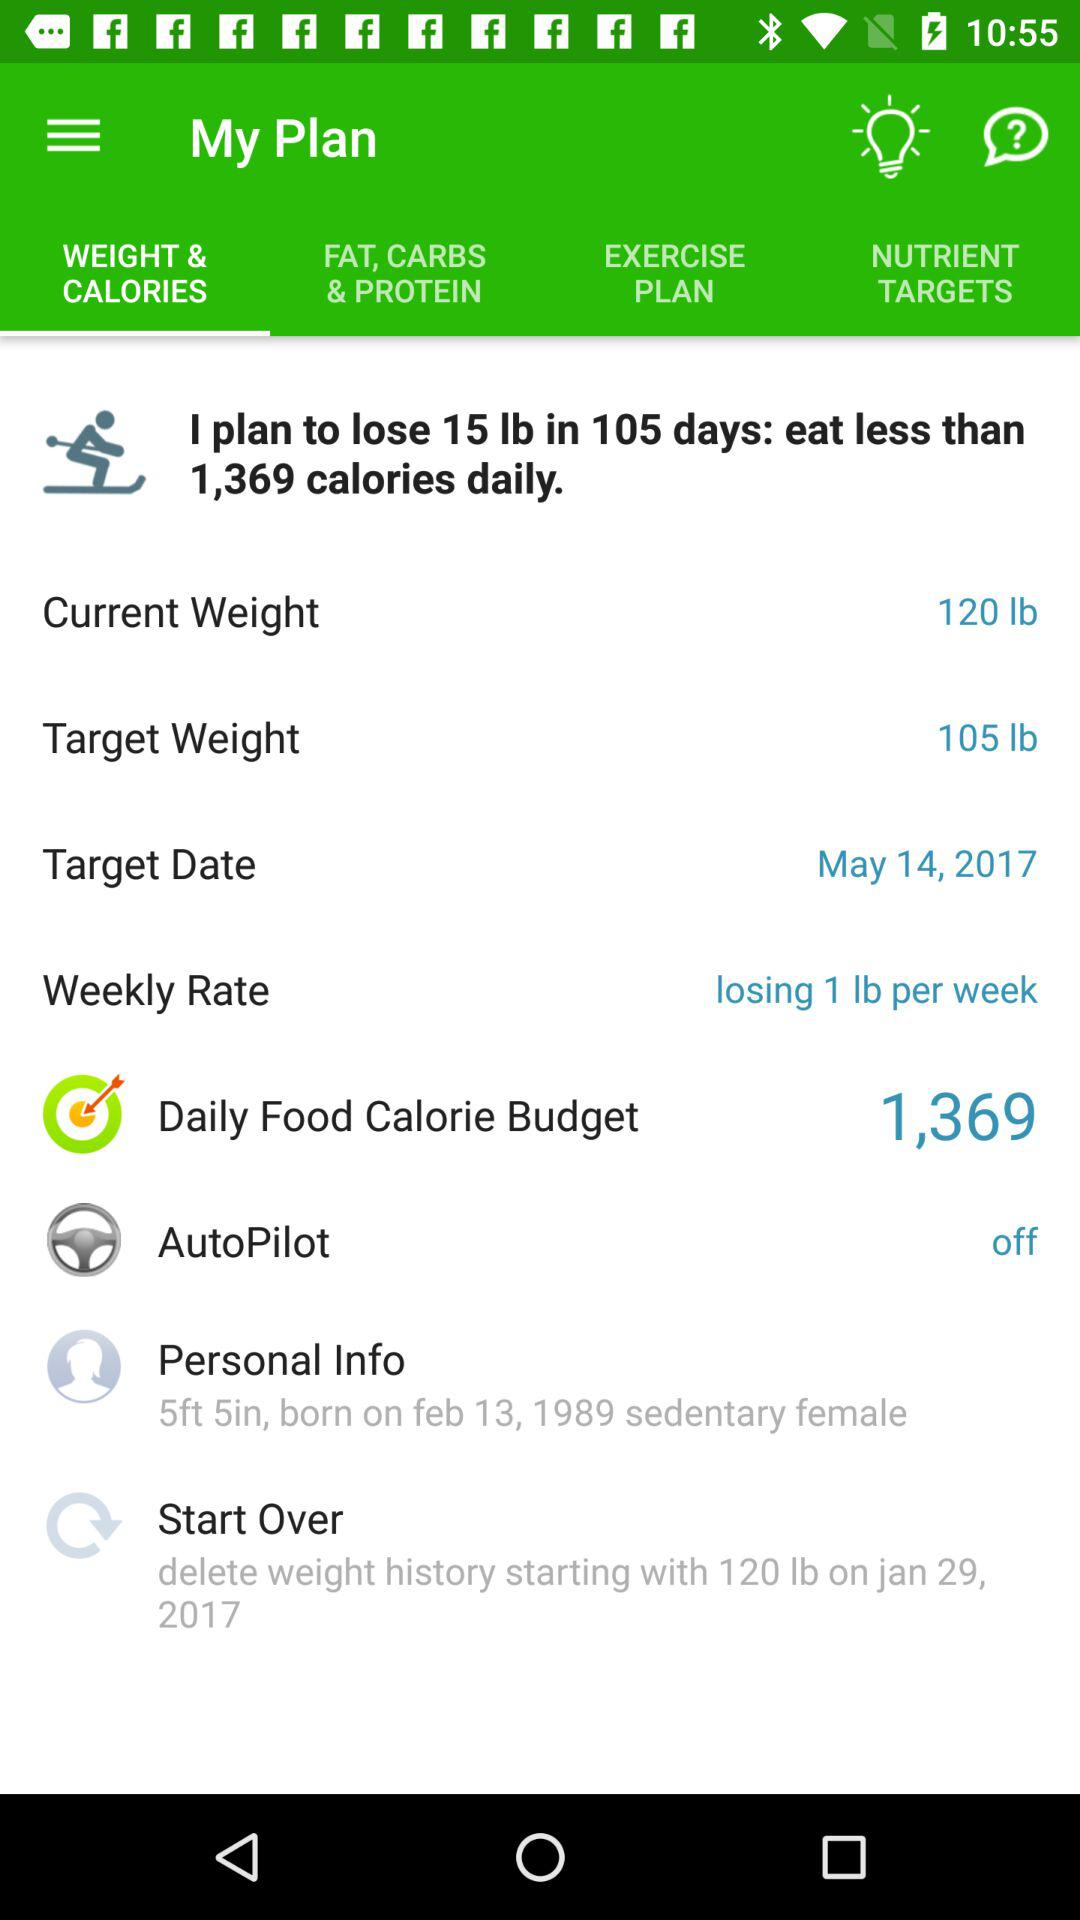How many calories do I have to eat per day to reach my goal?
Answer the question using a single word or phrase. 1,369 